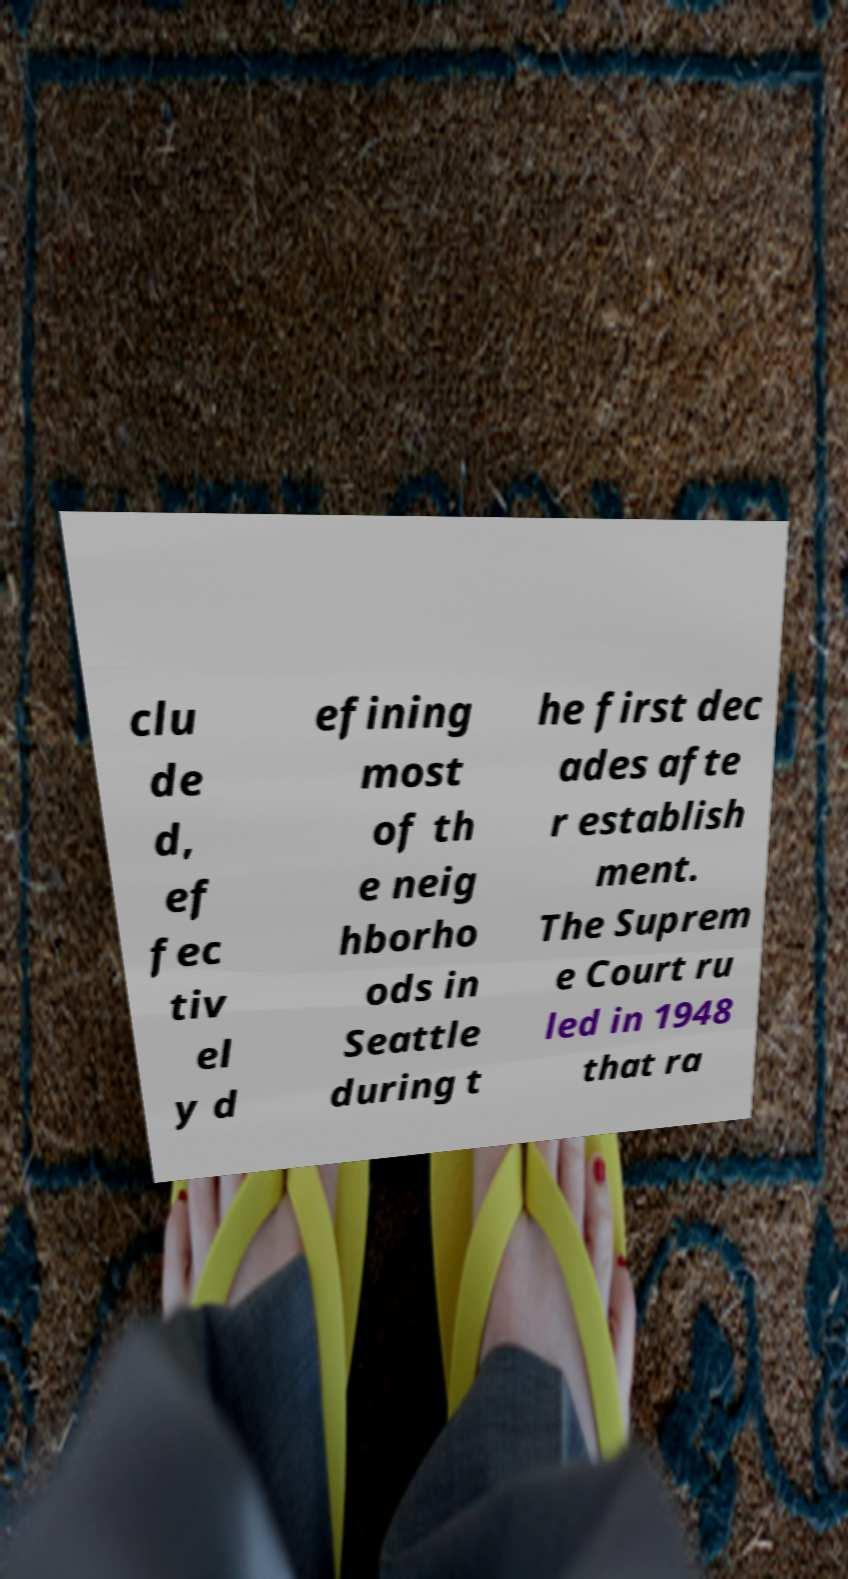Could you assist in decoding the text presented in this image and type it out clearly? clu de d, ef fec tiv el y d efining most of th e neig hborho ods in Seattle during t he first dec ades afte r establish ment. The Suprem e Court ru led in 1948 that ra 